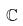<formula> <loc_0><loc_0><loc_500><loc_500>\mathbb { C }</formula> 